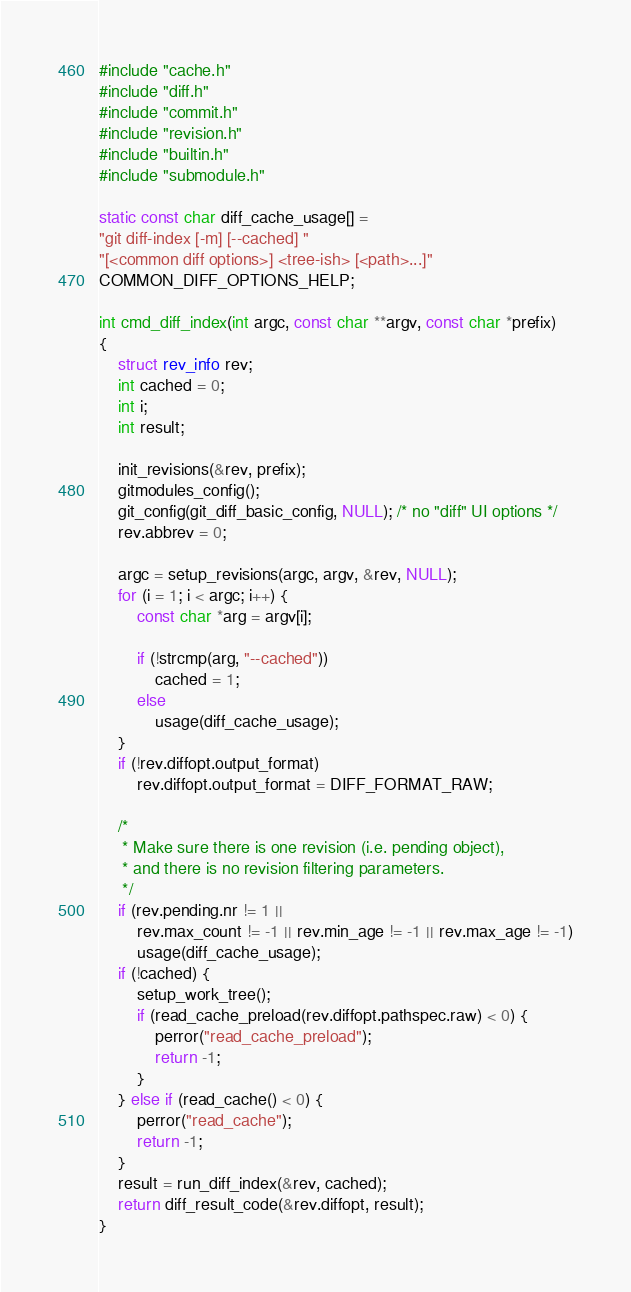Convert code to text. <code><loc_0><loc_0><loc_500><loc_500><_C_>#include "cache.h"
#include "diff.h"
#include "commit.h"
#include "revision.h"
#include "builtin.h"
#include "submodule.h"

static const char diff_cache_usage[] =
"git diff-index [-m] [--cached] "
"[<common diff options>] <tree-ish> [<path>...]"
COMMON_DIFF_OPTIONS_HELP;

int cmd_diff_index(int argc, const char **argv, const char *prefix)
{
	struct rev_info rev;
	int cached = 0;
	int i;
	int result;

	init_revisions(&rev, prefix);
	gitmodules_config();
	git_config(git_diff_basic_config, NULL); /* no "diff" UI options */
	rev.abbrev = 0;

	argc = setup_revisions(argc, argv, &rev, NULL);
	for (i = 1; i < argc; i++) {
		const char *arg = argv[i];

		if (!strcmp(arg, "--cached"))
			cached = 1;
		else
			usage(diff_cache_usage);
	}
	if (!rev.diffopt.output_format)
		rev.diffopt.output_format = DIFF_FORMAT_RAW;

	/*
	 * Make sure there is one revision (i.e. pending object),
	 * and there is no revision filtering parameters.
	 */
	if (rev.pending.nr != 1 ||
	    rev.max_count != -1 || rev.min_age != -1 || rev.max_age != -1)
		usage(diff_cache_usage);
	if (!cached) {
		setup_work_tree();
		if (read_cache_preload(rev.diffopt.pathspec.raw) < 0) {
			perror("read_cache_preload");
			return -1;
		}
	} else if (read_cache() < 0) {
		perror("read_cache");
		return -1;
	}
	result = run_diff_index(&rev, cached);
	return diff_result_code(&rev.diffopt, result);
}
</code> 